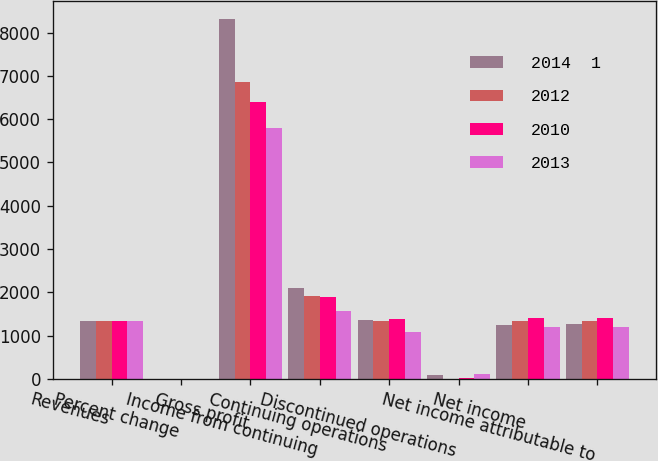<chart> <loc_0><loc_0><loc_500><loc_500><stacked_bar_chart><ecel><fcel>Revenues<fcel>Percent change<fcel>Gross profit<fcel>Income from continuing<fcel>Continuing operations<fcel>Discontinued operations<fcel>Net income<fcel>Net income attributable to<nl><fcel>2014  1<fcel>1338<fcel>12.7<fcel>8309<fcel>2096<fcel>1354<fcel>96<fcel>1258<fcel>1263<nl><fcel>2012<fcel>1338<fcel>0.2<fcel>6848<fcel>1928<fcel>1347<fcel>9<fcel>1338<fcel>1338<nl><fcel>2010<fcel>1338<fcel>9.5<fcel>6402<fcel>1893<fcel>1379<fcel>24<fcel>1403<fcel>1403<nl><fcel>2013<fcel>1338<fcel>3.1<fcel>5797<fcel>1579<fcel>1083<fcel>119<fcel>1202<fcel>1202<nl></chart> 